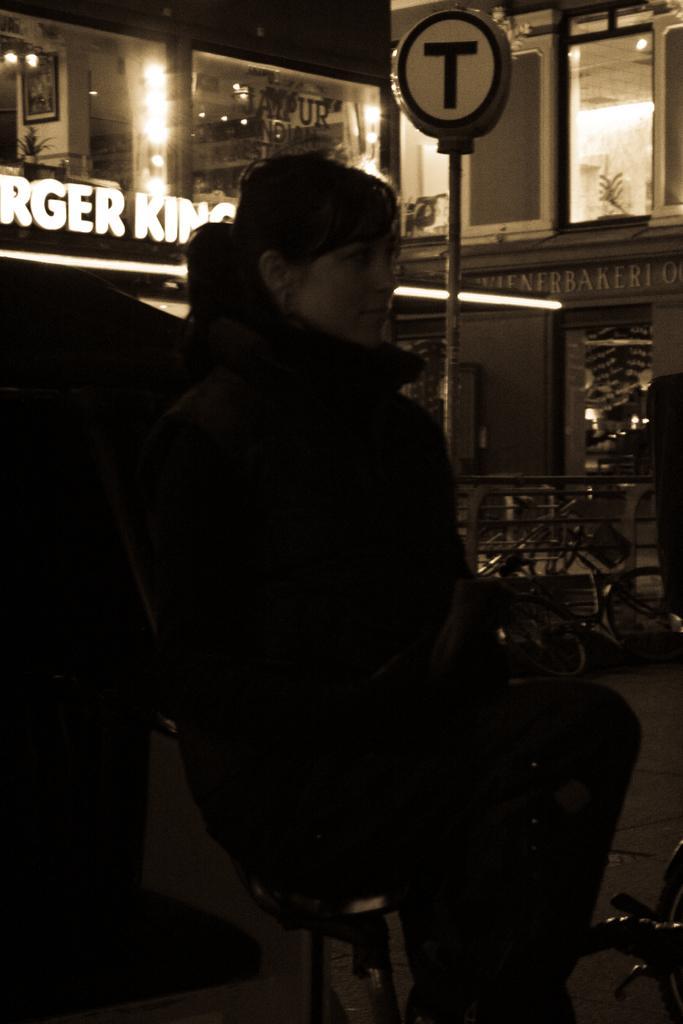Can you describe this image briefly? In the picture we can see a woman sitting on a stool and in front of her we can see a pole with board T on it and in the background, we can see the building with window and near to it we can see another building with a name burger king on it. 